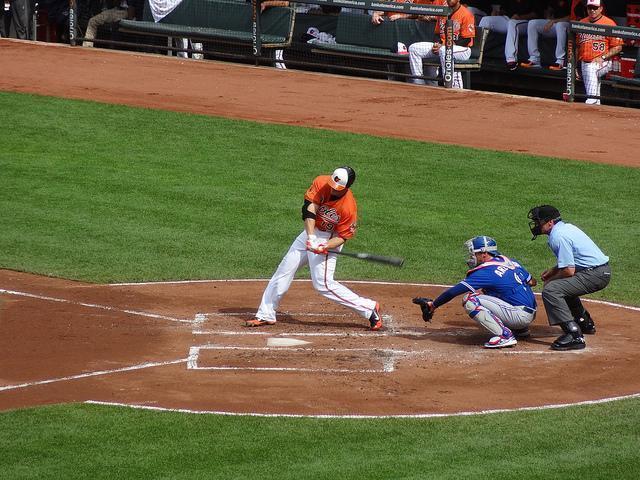How many people are on the field?
Give a very brief answer. 3. How many people are there?
Give a very brief answer. 6. 